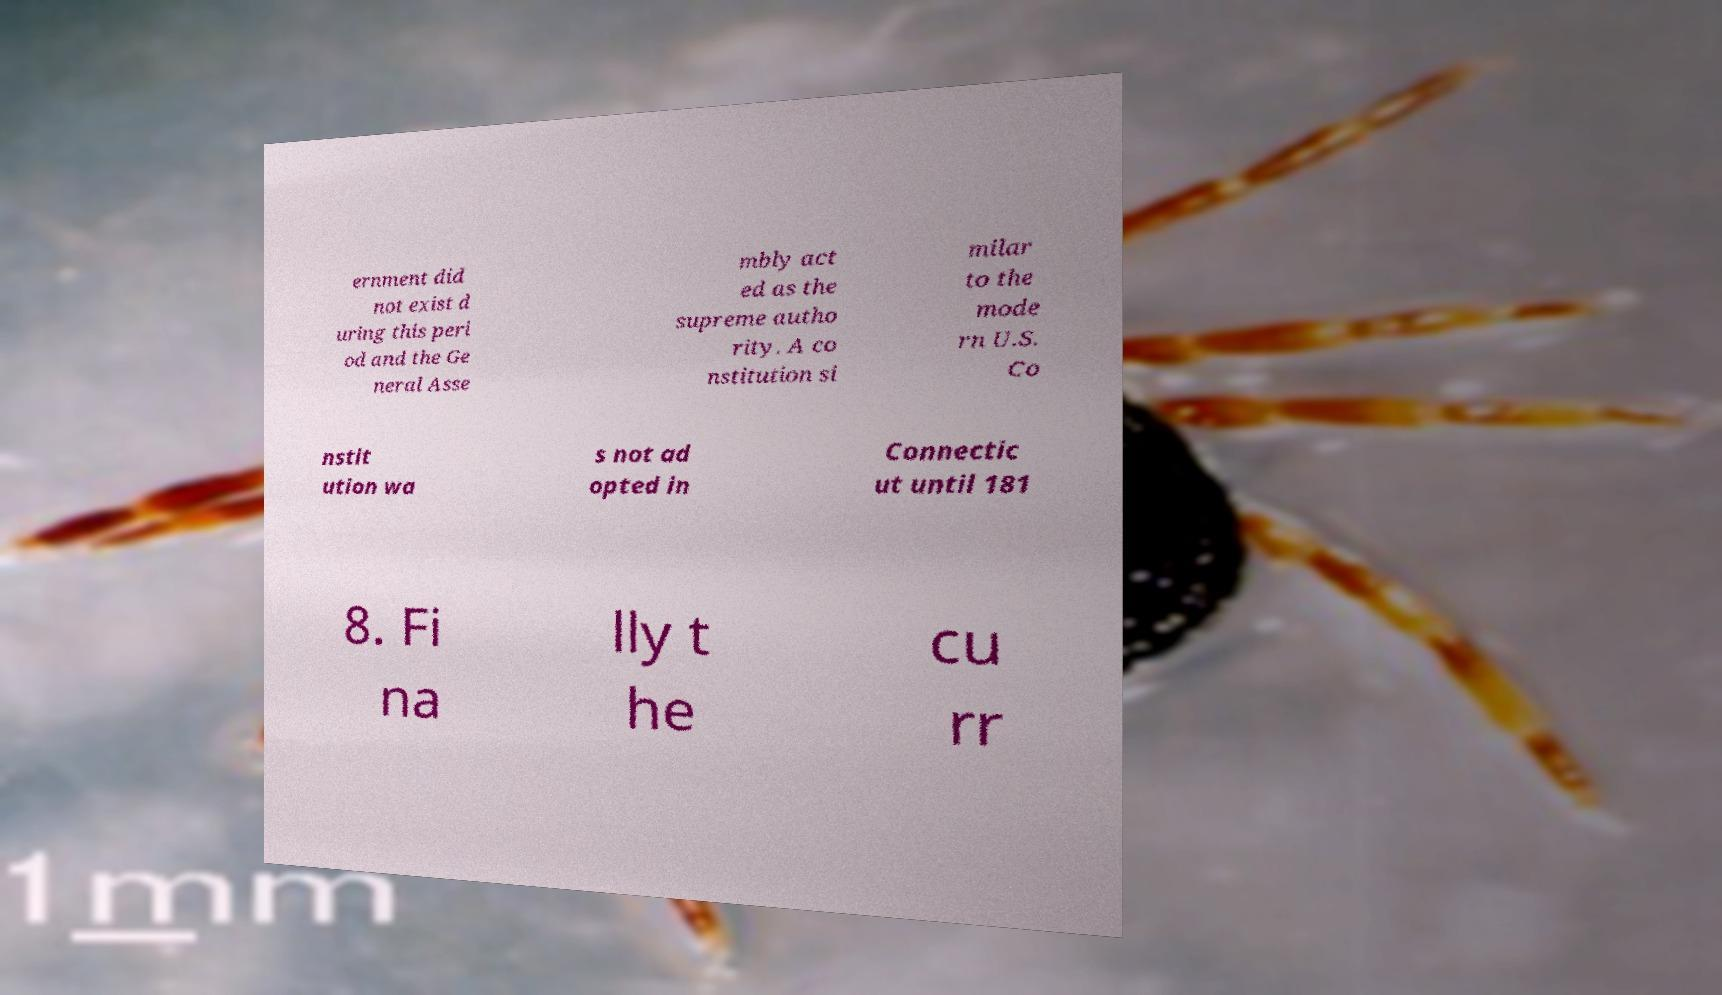Can you accurately transcribe the text from the provided image for me? ernment did not exist d uring this peri od and the Ge neral Asse mbly act ed as the supreme autho rity. A co nstitution si milar to the mode rn U.S. Co nstit ution wa s not ad opted in Connectic ut until 181 8. Fi na lly t he cu rr 